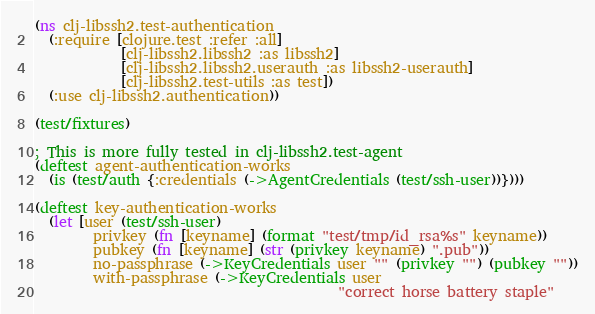Convert code to text. <code><loc_0><loc_0><loc_500><loc_500><_Clojure_>(ns clj-libssh2.test-authentication
  (:require [clojure.test :refer :all]
            [clj-libssh2.libssh2 :as libssh2]
            [clj-libssh2.libssh2.userauth :as libssh2-userauth]
            [clj-libssh2.test-utils :as test])
  (:use clj-libssh2.authentication))

(test/fixtures)

; This is more fully tested in clj-libssh2.test-agent
(deftest agent-authentication-works
  (is (test/auth {:credentials (->AgentCredentials (test/ssh-user))})))

(deftest key-authentication-works
  (let [user (test/ssh-user)
        privkey (fn [keyname] (format "test/tmp/id_rsa%s" keyname))
        pubkey (fn [keyname] (str (privkey keyname) ".pub"))
        no-passphrase (->KeyCredentials user "" (privkey "") (pubkey ""))
        with-passphrase (->KeyCredentials user
                                          "correct horse battery staple"</code> 